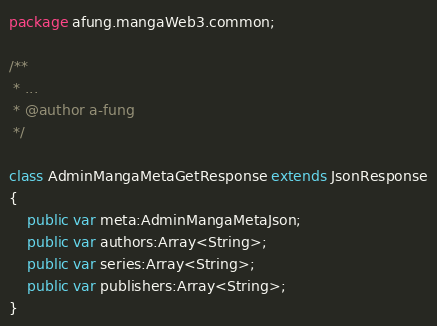Convert code to text. <code><loc_0><loc_0><loc_500><loc_500><_Haxe_>package afung.mangaWeb3.common;

/**
 * ...
 * @author a-fung
 */

class AdminMangaMetaGetResponse extends JsonResponse
{
    public var meta:AdminMangaMetaJson;
    public var authors:Array<String>;
    public var series:Array<String>;
    public var publishers:Array<String>;
}</code> 